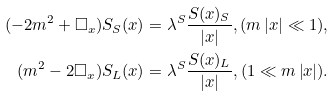<formula> <loc_0><loc_0><loc_500><loc_500>( - 2 m ^ { 2 } + \square _ { x } ) S _ { S } ( x ) & = \lambda ^ { S } \frac { S ( x ) _ { S } } { \left | x \right | } , ( m \left | x \right | \ll 1 ) , \\ ( m ^ { 2 } - 2 \square _ { x } ) S _ { L } ( x ) & = \lambda ^ { S } \frac { S ( x ) _ { L } } { \left | x \right | } , ( 1 \ll m \left | x \right | ) .</formula> 